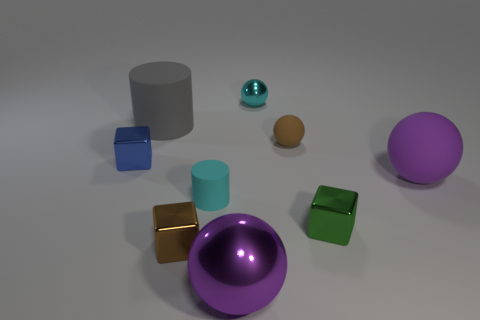What number of other brown rubber spheres are the same size as the brown matte sphere?
Provide a short and direct response. 0. There is a large ball that is on the left side of the small green thing; what number of tiny green blocks are left of it?
Provide a succinct answer. 0. There is a tiny shiny cube behind the purple rubber object; does it have the same color as the big metal ball?
Your answer should be very brief. No. There is a purple thing that is on the right side of the purple sphere in front of the tiny green cube; are there any shiny things behind it?
Your answer should be compact. Yes. The metal object that is on the right side of the big rubber cylinder and behind the large purple matte thing has what shape?
Provide a short and direct response. Sphere. Are there any small metal objects that have the same color as the tiny cylinder?
Provide a succinct answer. Yes. There is a block that is to the right of the cylinder that is to the right of the brown metallic object; what color is it?
Your answer should be compact. Green. What is the size of the cyan object behind the large ball behind the rubber cylinder in front of the big gray cylinder?
Make the answer very short. Small. Does the tiny blue cube have the same material as the sphere behind the tiny brown rubber sphere?
Make the answer very short. Yes. There is a purple object that is made of the same material as the small brown cube; what size is it?
Make the answer very short. Large. 